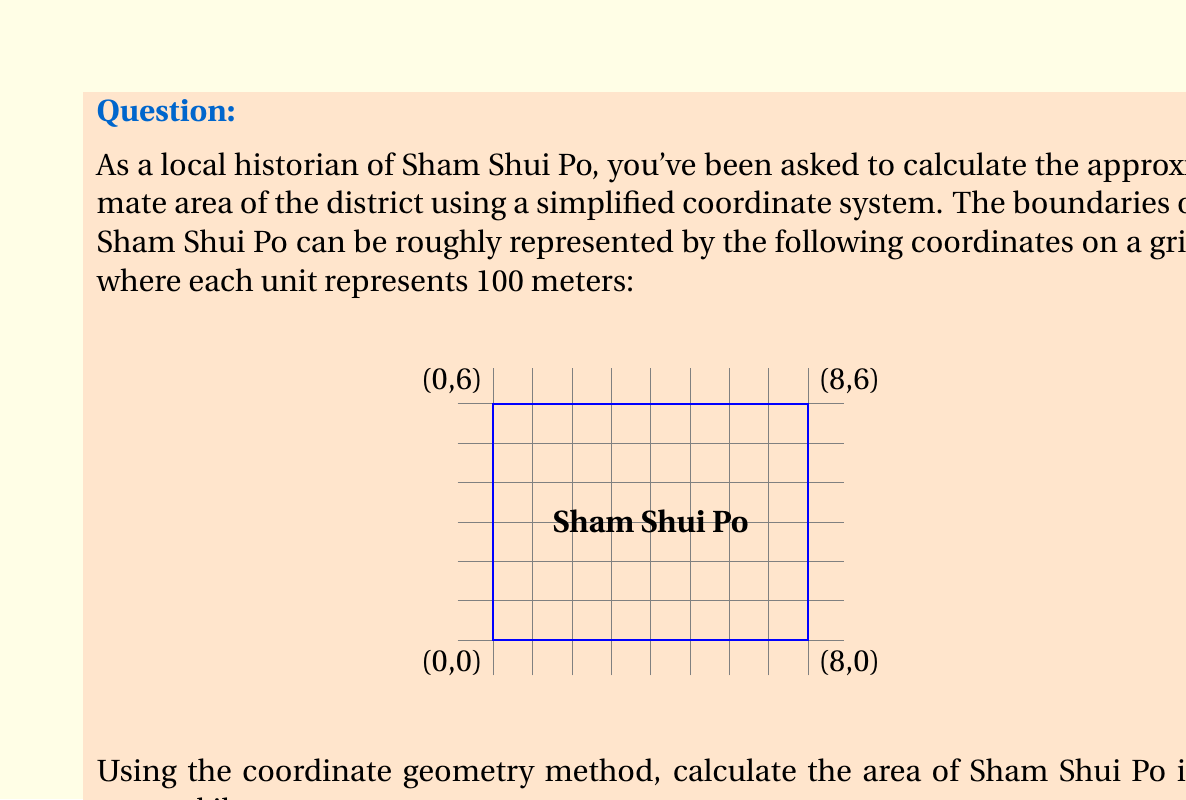Solve this math problem. To calculate the area of Sham Shui Po using coordinate geometry, we'll use the Shoelace formula (also known as the surveyor's formula). This method calculates the area of a polygon given the coordinates of its vertices.

The formula is:

$$ A = \frac{1}{2}|\sum_{i=1}^{n-1} (x_i y_{i+1} - x_{i+1} y_i) + (x_n y_1 - x_1 y_n)| $$

Where $(x_i, y_i)$ are the coordinates of the $i$-th vertex.

Given coordinates:
(0,0), (8,0), (8,6), (0,6)

Step 1: Apply the formula
$$ A = \frac{1}{2}|(0 \cdot 0 - 8 \cdot 0) + (8 \cdot 6 - 8 \cdot 6) + (8 \cdot 6 - 0 \cdot 6) + (0 \cdot 0 - 0 \cdot 0)| $$

Step 2: Simplify
$$ A = \frac{1}{2}|0 + 0 + 48 + 0| = \frac{1}{2} \cdot 48 = 24 $$

Step 3: Convert to real-world units
Each unit represents 100 meters, so the area in square meters is:
$$ 24 \cdot (100 \text{ m})^2 = 240,000 \text{ m}^2 $$

Step 4: Convert to square kilometers
$$ 240,000 \text{ m}^2 = 0.24 \text{ km}^2 $$

Therefore, the approximate area of Sham Shui Po is 0.24 square kilometers.
Answer: 0.24 km² 